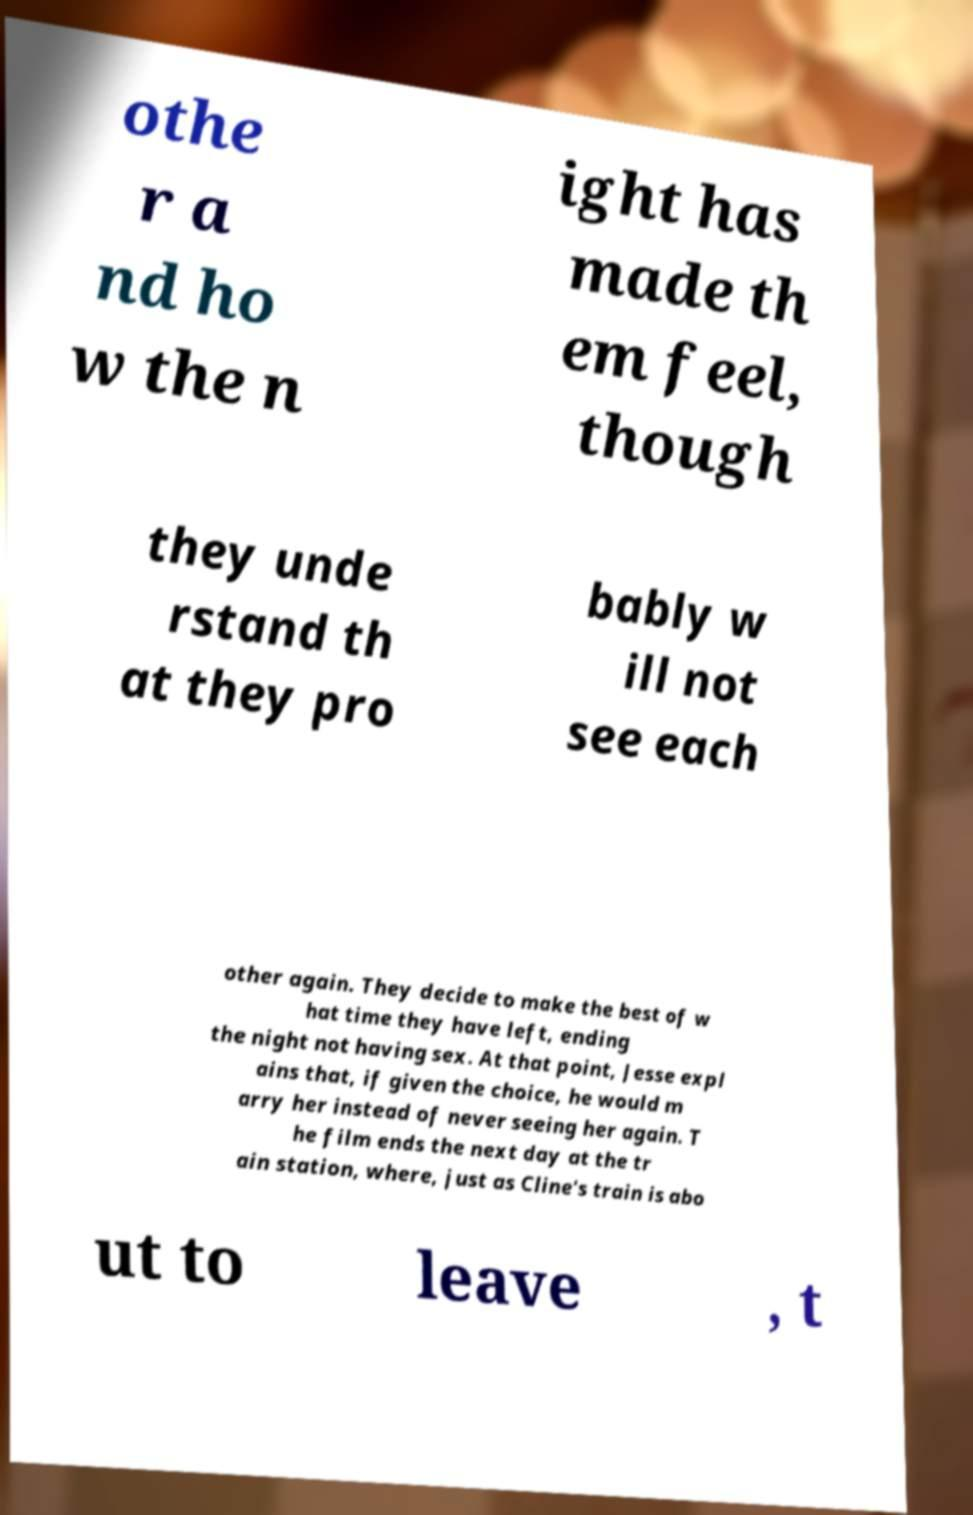Please identify and transcribe the text found in this image. othe r a nd ho w the n ight has made th em feel, though they unde rstand th at they pro bably w ill not see each other again. They decide to make the best of w hat time they have left, ending the night not having sex. At that point, Jesse expl ains that, if given the choice, he would m arry her instead of never seeing her again. T he film ends the next day at the tr ain station, where, just as Cline's train is abo ut to leave , t 